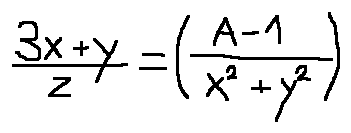<formula> <loc_0><loc_0><loc_500><loc_500>\frac { 3 x + y } { z } = ( \frac { A - 1 } { x ^ { 2 } + y ^ { 2 } } )</formula> 